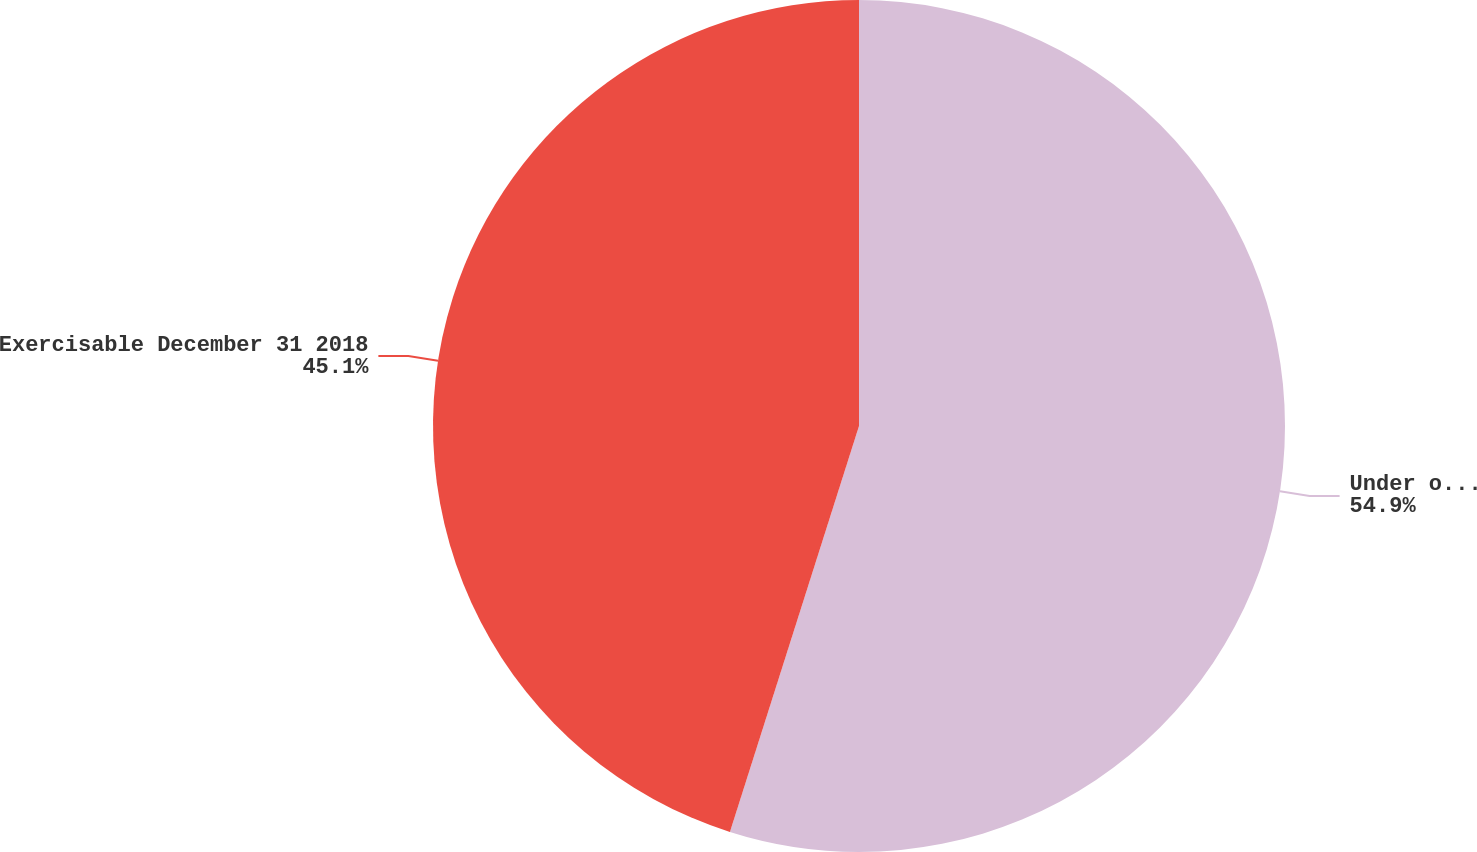<chart> <loc_0><loc_0><loc_500><loc_500><pie_chart><fcel>Under option December 31 2018<fcel>Exercisable December 31 2018<nl><fcel>54.9%<fcel>45.1%<nl></chart> 